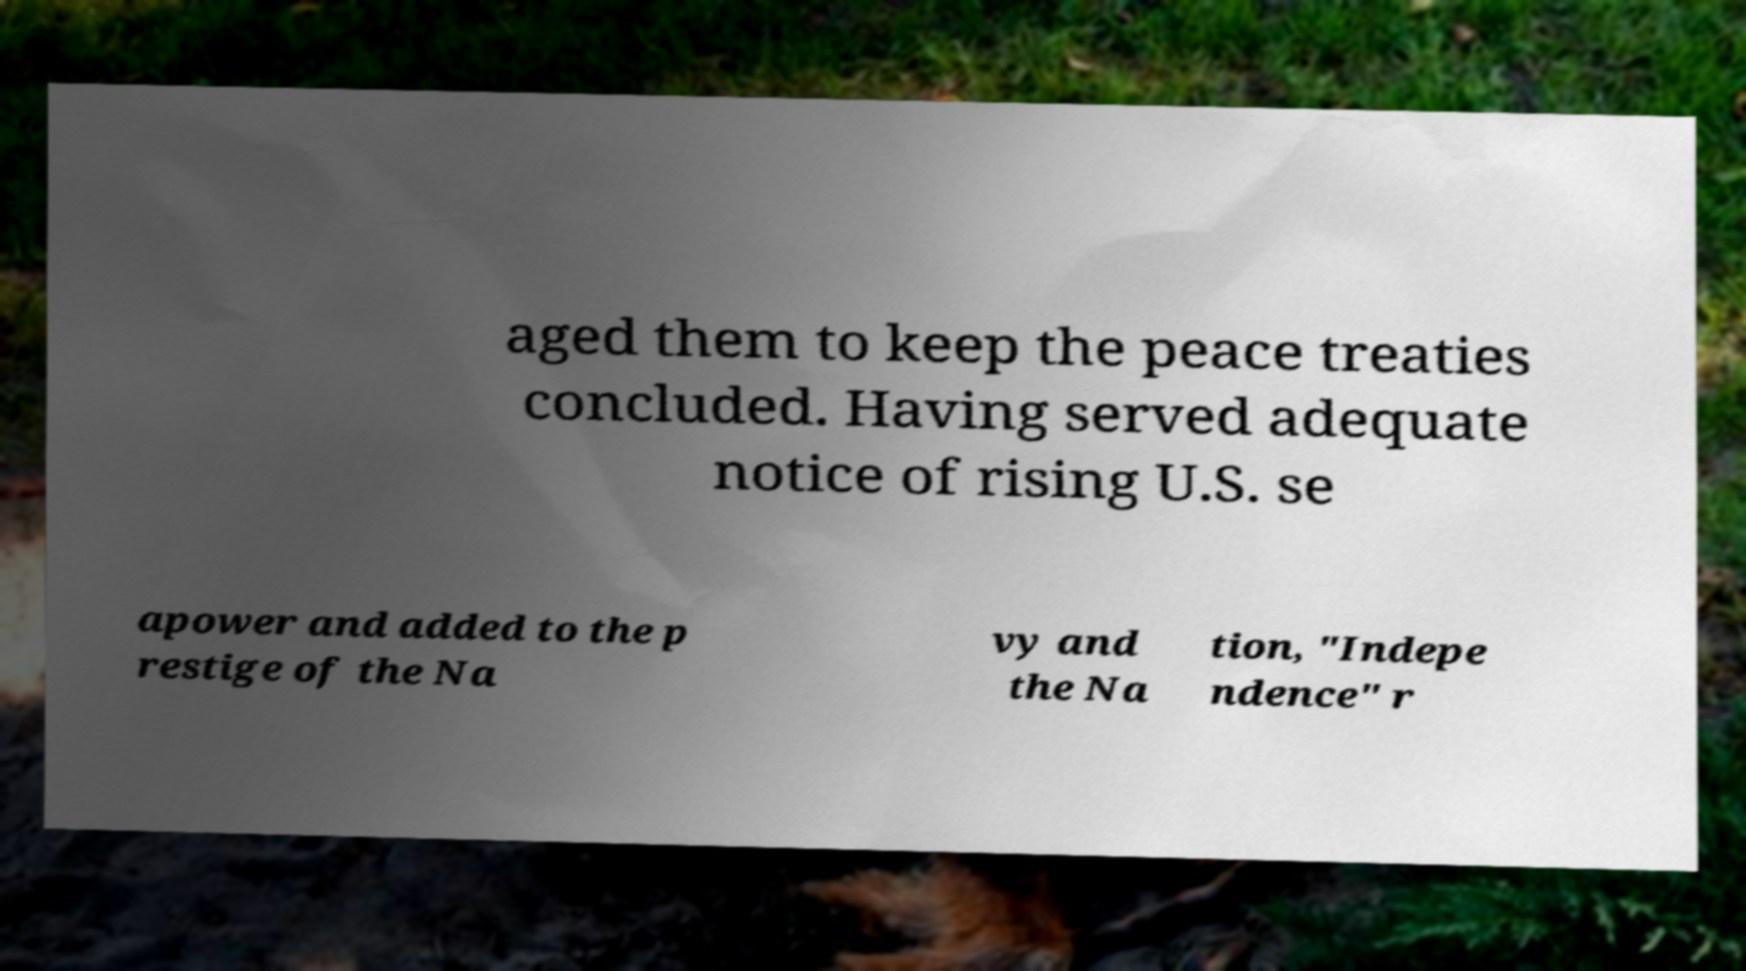I need the written content from this picture converted into text. Can you do that? aged them to keep the peace treaties concluded. Having served adequate notice of rising U.S. se apower and added to the p restige of the Na vy and the Na tion, "Indepe ndence" r 